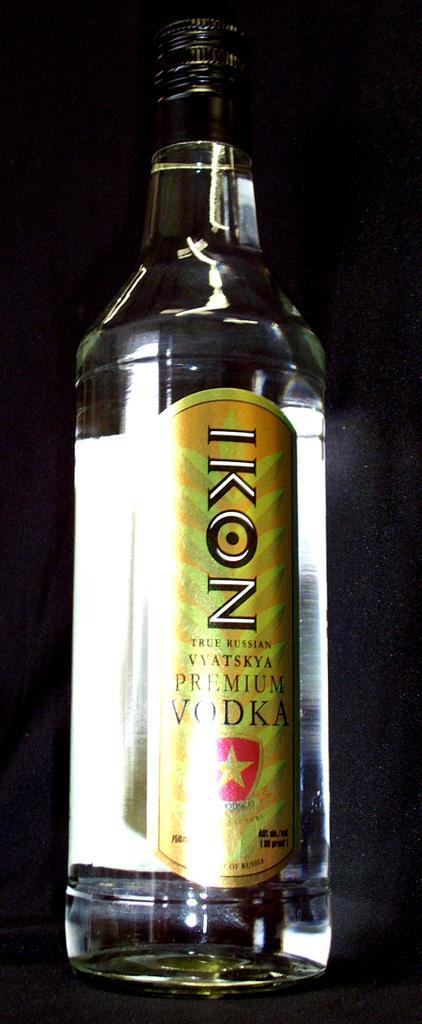How would you summarize this image in a sentence or two? There is a vodka bottle on the table. 